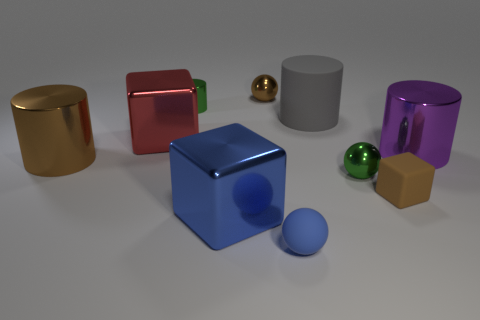Subtract all balls. How many objects are left? 7 Add 8 large blue metallic blocks. How many large blue metallic blocks are left? 9 Add 1 large blue metallic things. How many large blue metallic things exist? 2 Subtract 1 gray cylinders. How many objects are left? 9 Subtract all big metallic cubes. Subtract all blocks. How many objects are left? 5 